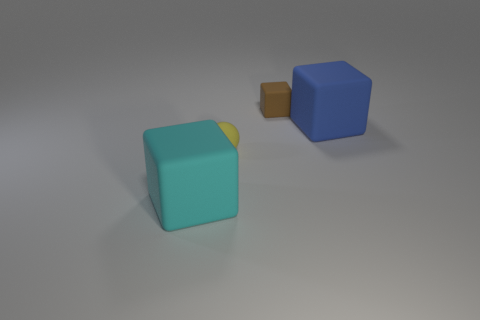What is the material of the brown thing that is the same shape as the big cyan object?
Provide a short and direct response. Rubber. How many other objects are there of the same size as the brown object?
Make the answer very short. 1. What material is the tiny brown object?
Give a very brief answer. Rubber. Is the number of big cyan matte cubes on the right side of the tiny yellow object greater than the number of tiny matte balls?
Provide a short and direct response. No. Are there any cyan things?
Provide a succinct answer. Yes. What number of other objects are the same shape as the tiny yellow thing?
Provide a succinct answer. 0. Does the big thing that is in front of the blue rubber block have the same color as the big rubber block behind the yellow matte sphere?
Give a very brief answer. No. How big is the object that is behind the big matte block behind the big rubber thing in front of the yellow matte thing?
Ensure brevity in your answer.  Small. There is a object that is both in front of the blue block and right of the cyan rubber block; what shape is it?
Your response must be concise. Sphere. Are there the same number of brown rubber objects left of the big blue object and yellow spheres in front of the large cyan matte block?
Make the answer very short. No. 